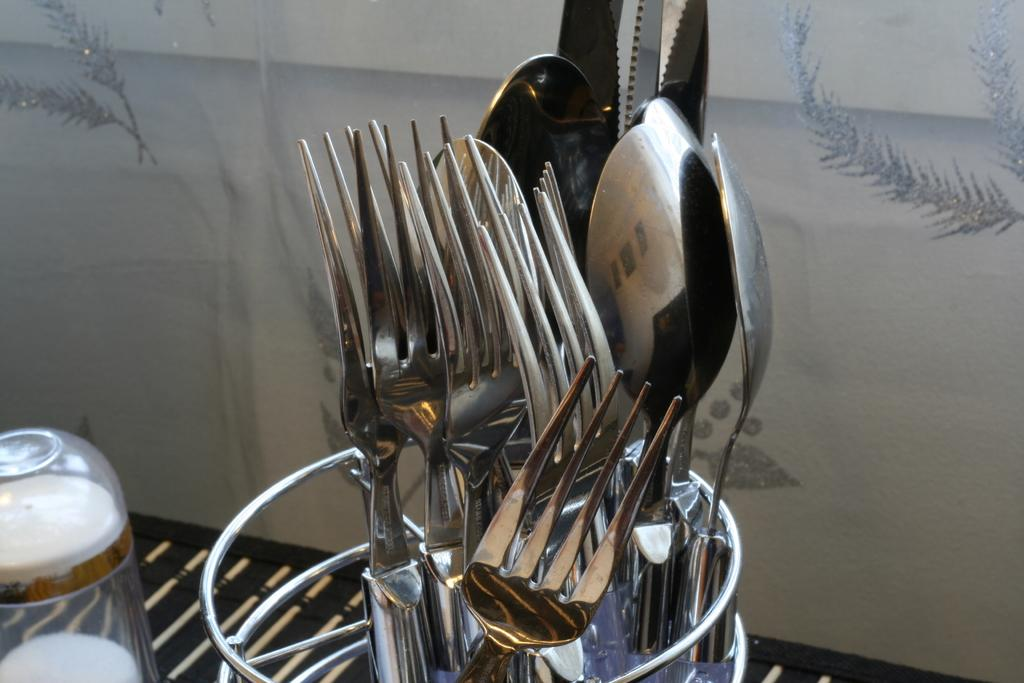What type of objects can be seen in the image? There are utensils in the image. Where are the objects located in the image? The objects are in the bottom left of the image. What can be seen behind the utensils? There is a wall visible behind the utensils. What is special about the wall? There are designs on the wall. What type of government is depicted on the wall in the image? There is no government depicted on the wall in the image; it features designs instead. Can you see a badge on any of the utensils in the image? There are no badges present on the utensils in the image. 